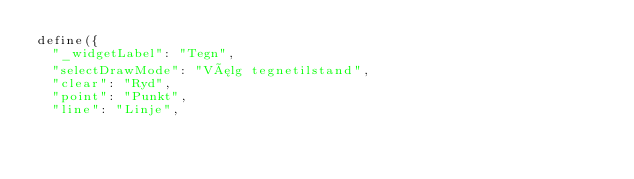Convert code to text. <code><loc_0><loc_0><loc_500><loc_500><_JavaScript_>define({
  "_widgetLabel": "Tegn",
  "selectDrawMode": "Vælg tegnetilstand",
  "clear": "Ryd",
  "point": "Punkt",
  "line": "Linje",</code> 